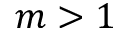<formula> <loc_0><loc_0><loc_500><loc_500>m > 1</formula> 